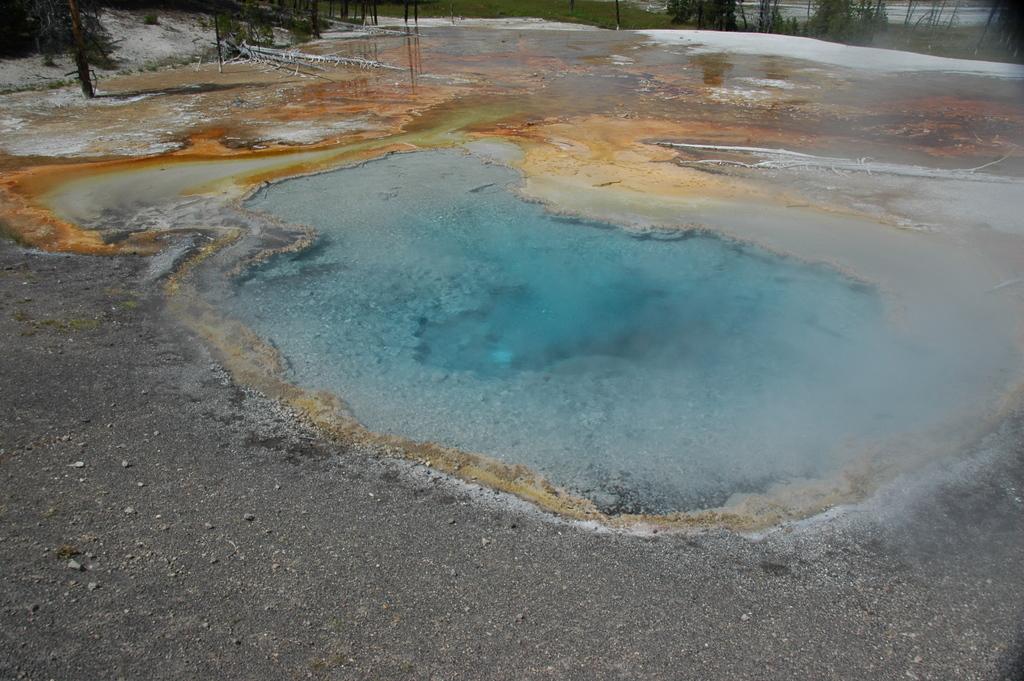Could you give a brief overview of what you see in this image? This picture shows water and we see trees 